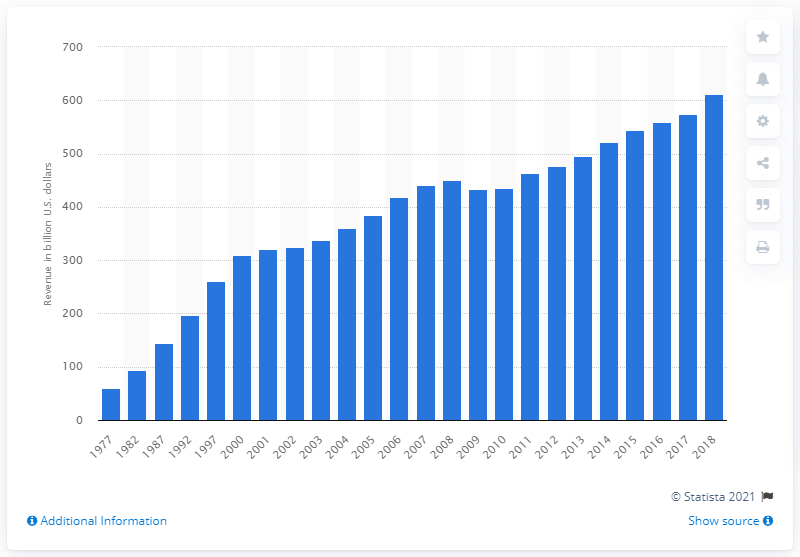Indicate a few pertinent items in this graphic. In 2018, state and local governments collected a total of $574.25 in tax revenue. In 2018, state and local governments collected a total of $611.37 in tax revenue. 